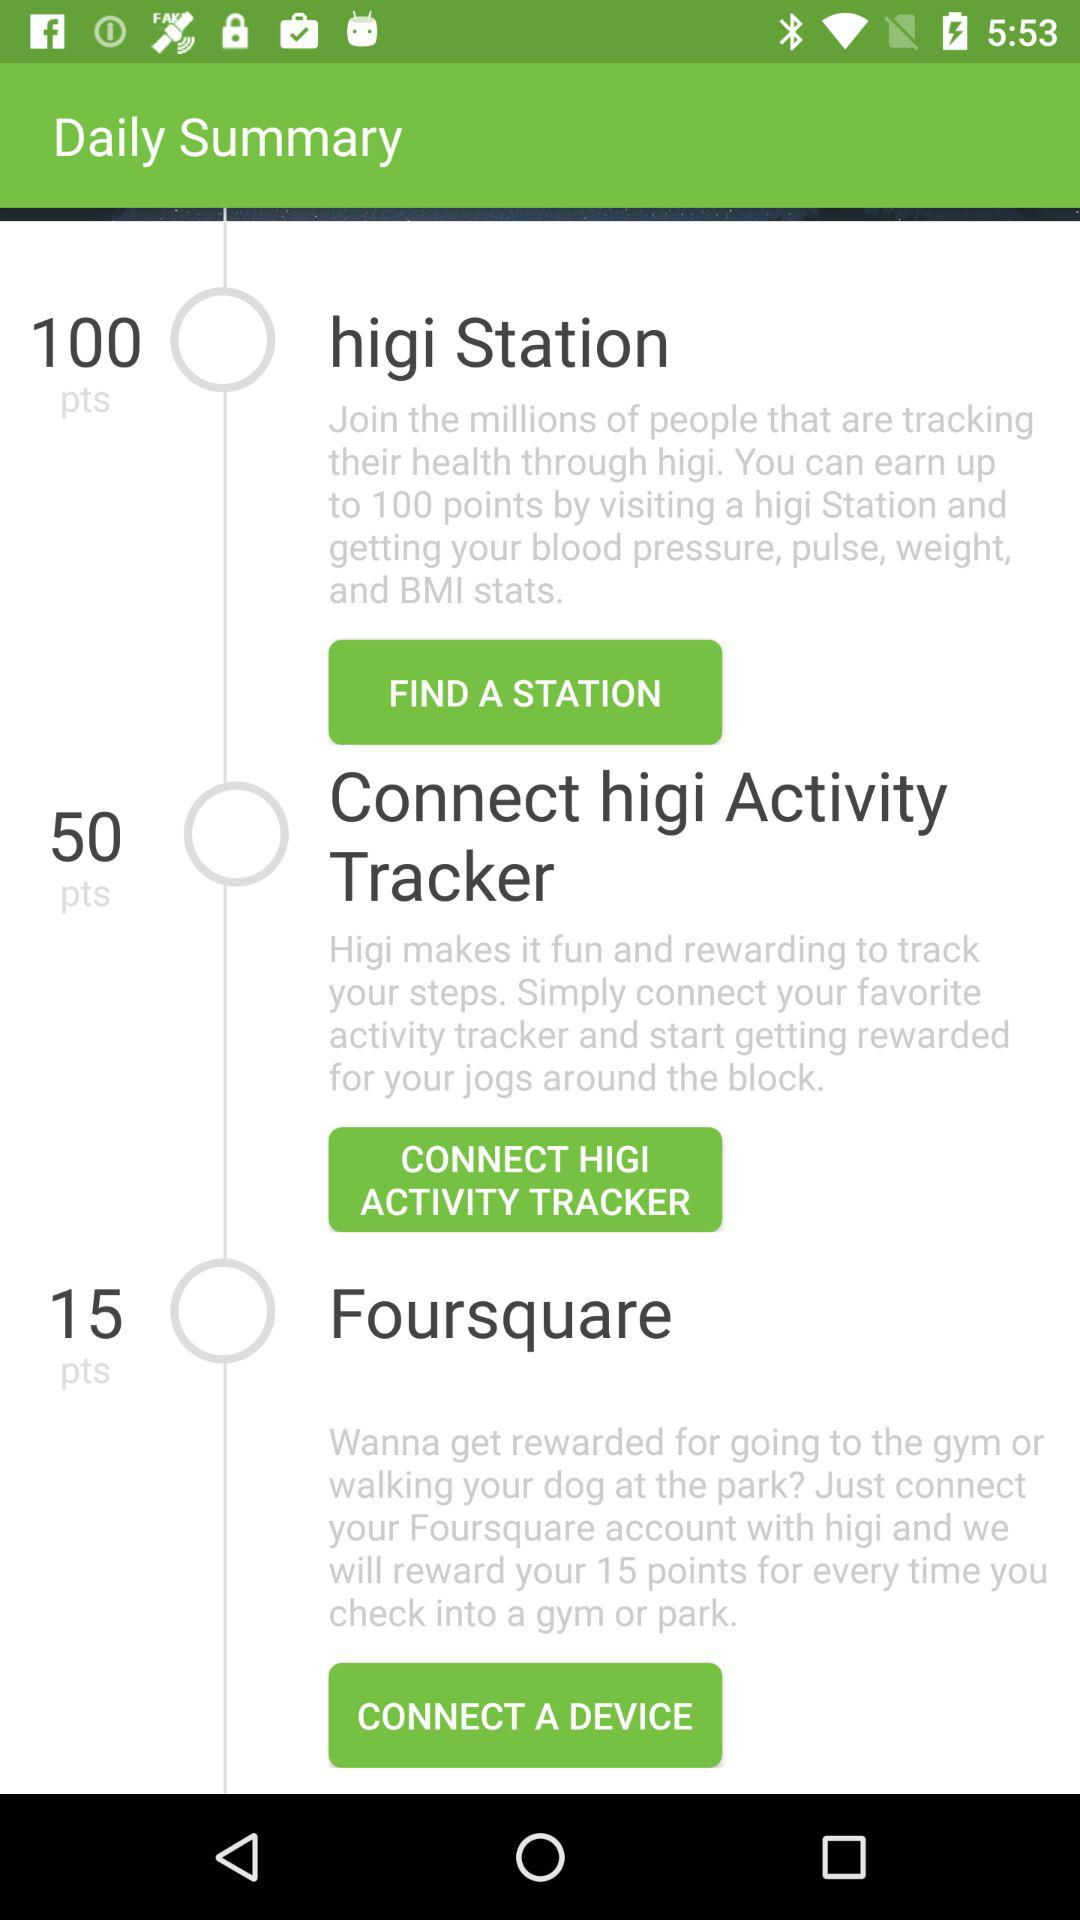How many points can we earn at "higi Station"? You can earn up to 100 points. 